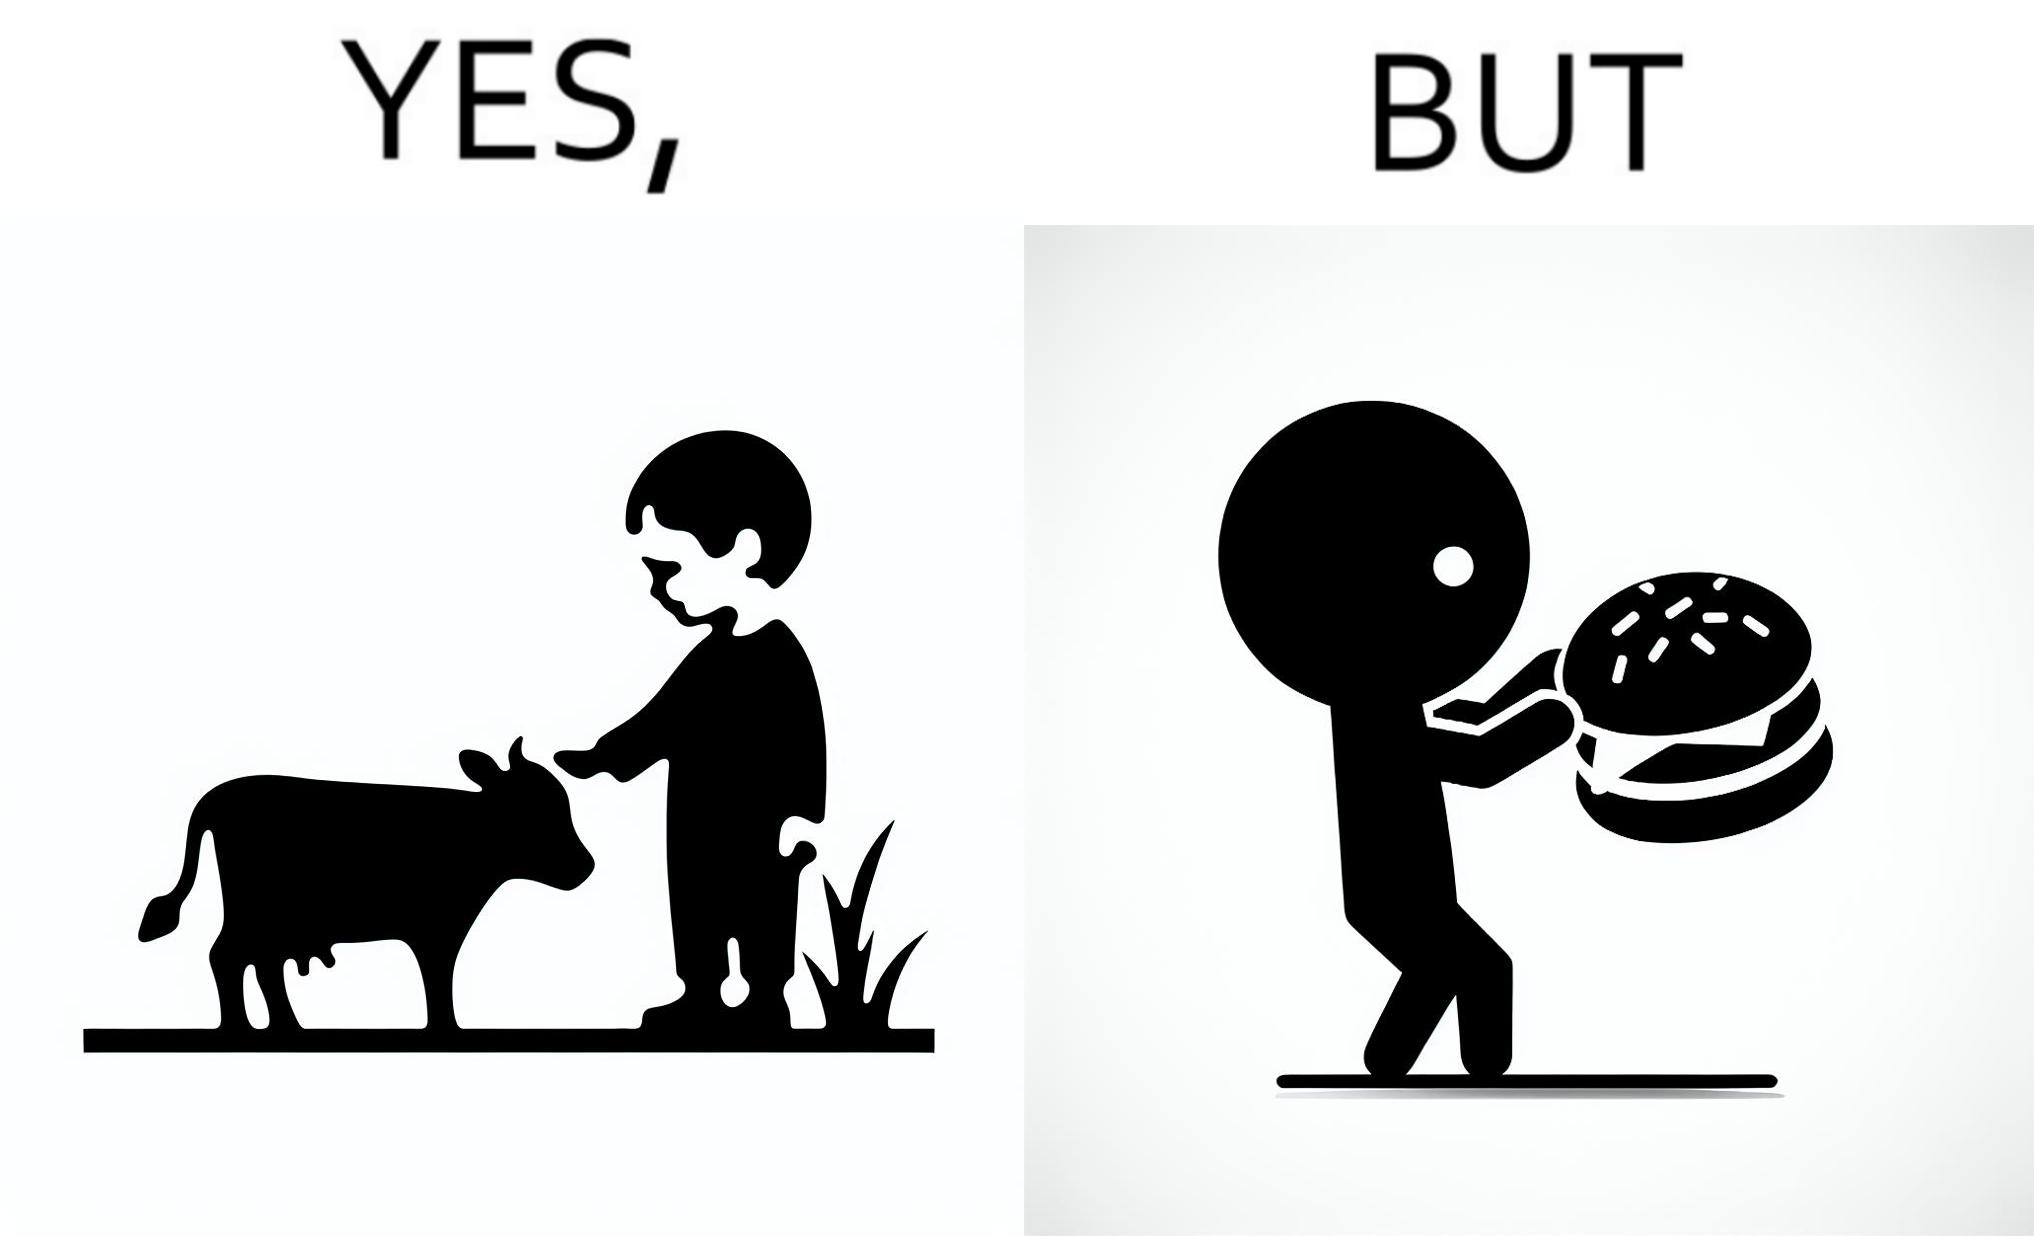Is there satirical content in this image? Yes, this image is satirical. 